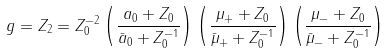<formula> <loc_0><loc_0><loc_500><loc_500>g = Z _ { 2 } = Z _ { 0 } ^ { - 2 } \left ( \frac { a _ { 0 } + Z _ { 0 } } { \bar { a } _ { 0 } + Z _ { 0 } ^ { - 1 } } \right ) \left ( \frac { \mu _ { + } + Z _ { 0 } } { \bar { \mu } _ { + } + Z _ { 0 } ^ { - 1 } } \right ) \left ( \frac { \mu _ { - } + Z _ { 0 } } { \bar { \mu } _ { - } + Z _ { 0 } ^ { - 1 } } \right )</formula> 